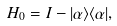<formula> <loc_0><loc_0><loc_500><loc_500>H _ { 0 } = I - | \alpha \rangle \langle \alpha | ,</formula> 